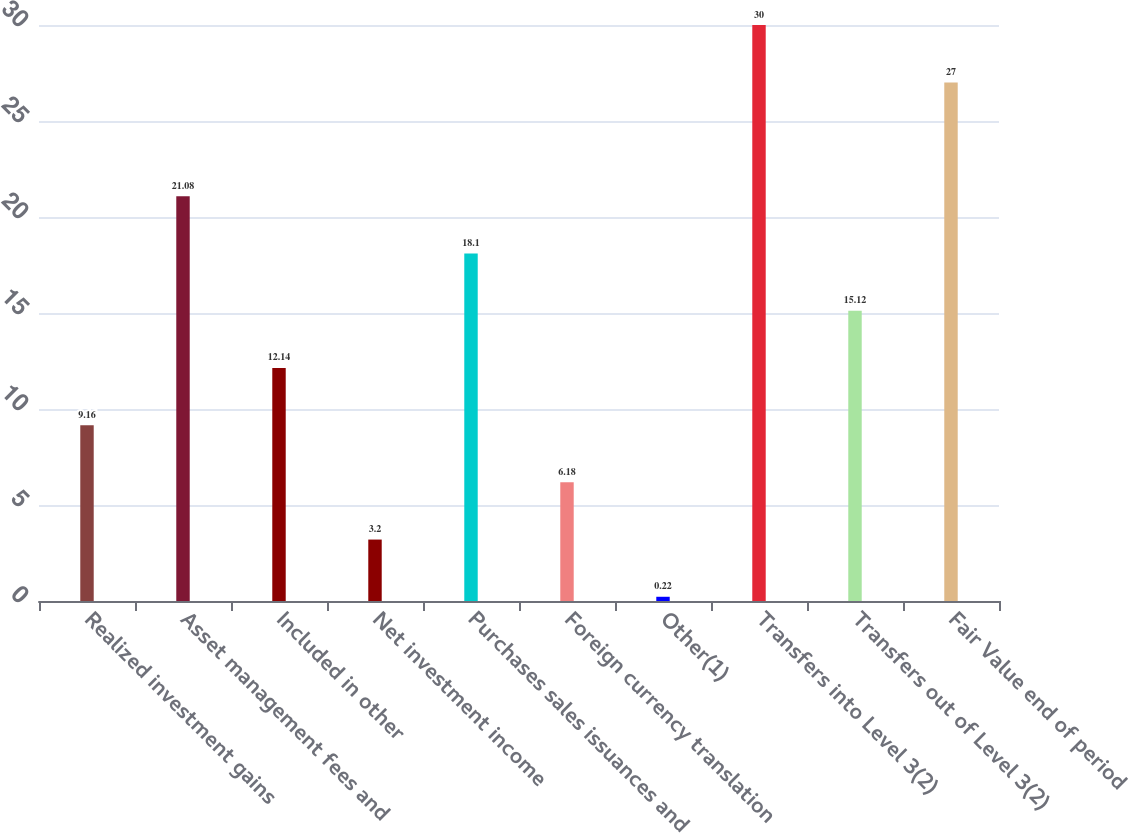<chart> <loc_0><loc_0><loc_500><loc_500><bar_chart><fcel>Realized investment gains<fcel>Asset management fees and<fcel>Included in other<fcel>Net investment income<fcel>Purchases sales issuances and<fcel>Foreign currency translation<fcel>Other(1)<fcel>Transfers into Level 3(2)<fcel>Transfers out of Level 3(2)<fcel>Fair Value end of period<nl><fcel>9.16<fcel>21.08<fcel>12.14<fcel>3.2<fcel>18.1<fcel>6.18<fcel>0.22<fcel>30<fcel>15.12<fcel>27<nl></chart> 